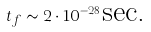Convert formula to latex. <formula><loc_0><loc_0><loc_500><loc_500>t _ { f } \sim 2 \cdot 1 0 ^ { - 2 8 } \text {sec.}</formula> 